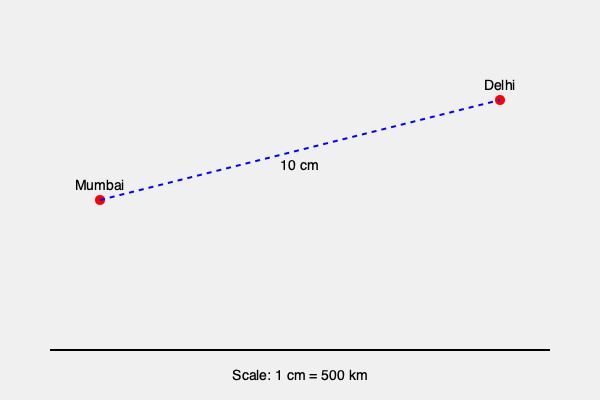On a world map, the distance between Mumbai and Delhi is represented by a 10 cm line. If the scale of the map is 1 cm = 500 km, what is the actual distance between these two major Indian cities? To calculate the actual distance between Mumbai and Delhi, we need to follow these steps:

1. Identify the scale: 1 cm on the map represents 500 km in real distance.

2. Measure the distance on the map: The question states that the distance between Mumbai and Delhi is represented by a 10 cm line.

3. Set up the proportion:
   $1 \text{ cm} : 500 \text{ km} = 10 \text{ cm} : x \text{ km}$

4. Solve for $x$ using cross multiplication:
   $1x = 10 \times 500$
   $x = 5000$

Therefore, the actual distance between Mumbai and Delhi is 5000 km.

To verify:
$10 \text{ cm} \times \frac{500 \text{ km}}{1 \text{ cm}} = 5000 \text{ km}$

This calculation demonstrates how map scales are used to determine real-world distances, which is particularly relevant for an international student from India studying at the University of King's College.
Answer: 5000 km 